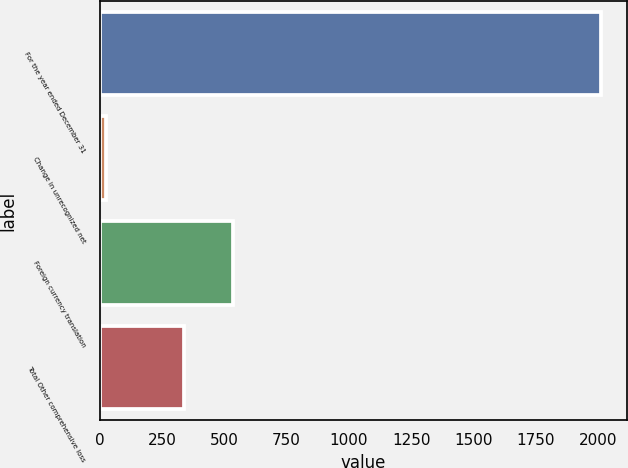Convert chart to OTSL. <chart><loc_0><loc_0><loc_500><loc_500><bar_chart><fcel>For the year ended December 31<fcel>Change in unrecognized net<fcel>Foreign currency translation<fcel>Total Other comprehensive loss<nl><fcel>2013<fcel>26<fcel>536.7<fcel>338<nl></chart> 